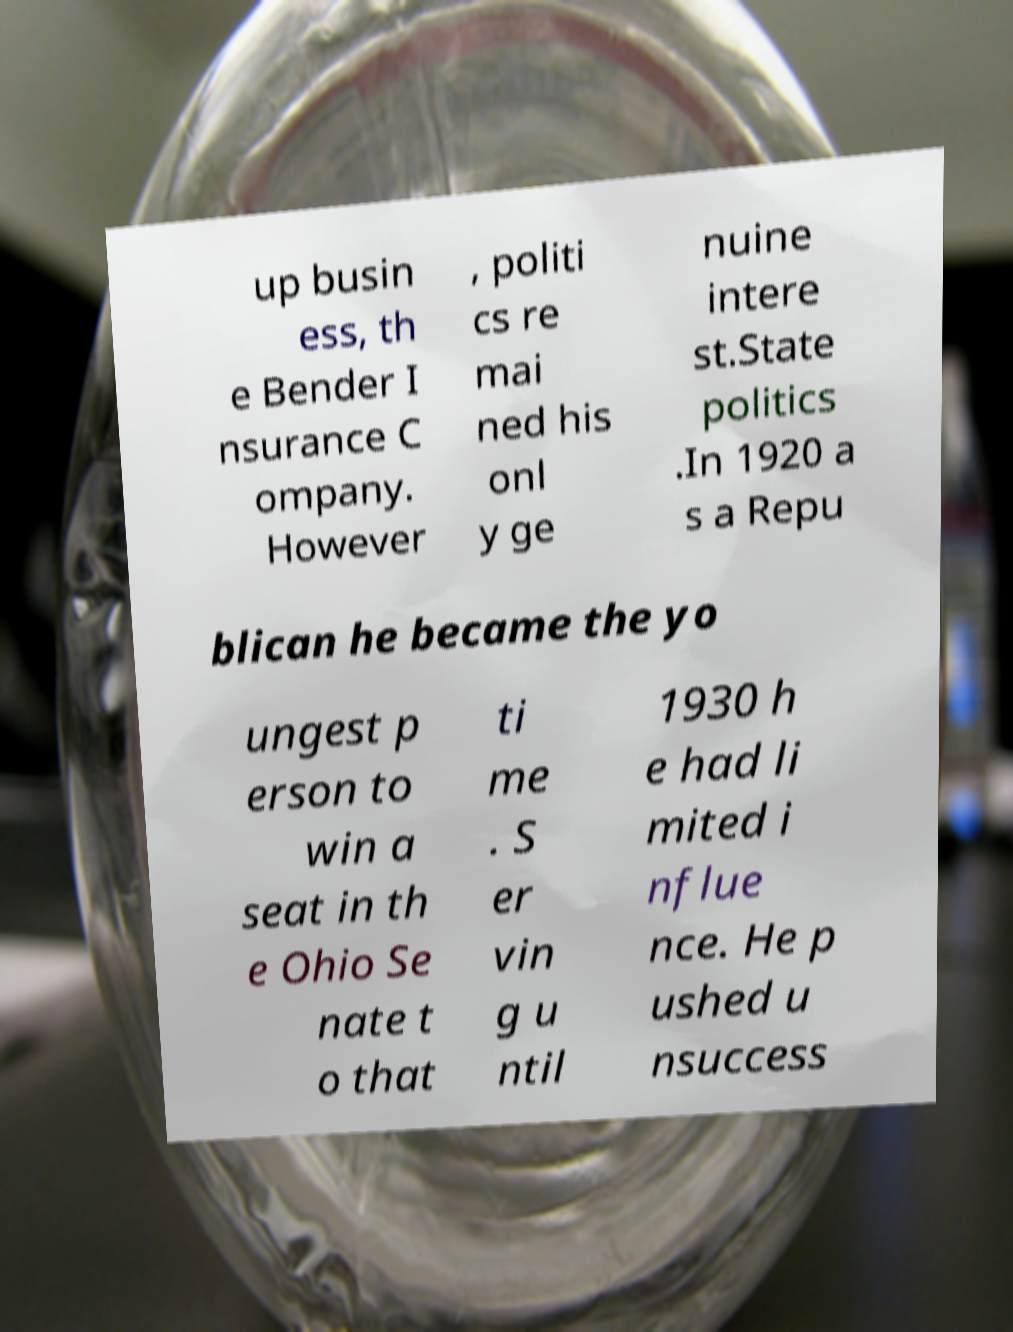Could you extract and type out the text from this image? up busin ess, th e Bender I nsurance C ompany. However , politi cs re mai ned his onl y ge nuine intere st.State politics .In 1920 a s a Repu blican he became the yo ungest p erson to win a seat in th e Ohio Se nate t o that ti me . S er vin g u ntil 1930 h e had li mited i nflue nce. He p ushed u nsuccess 